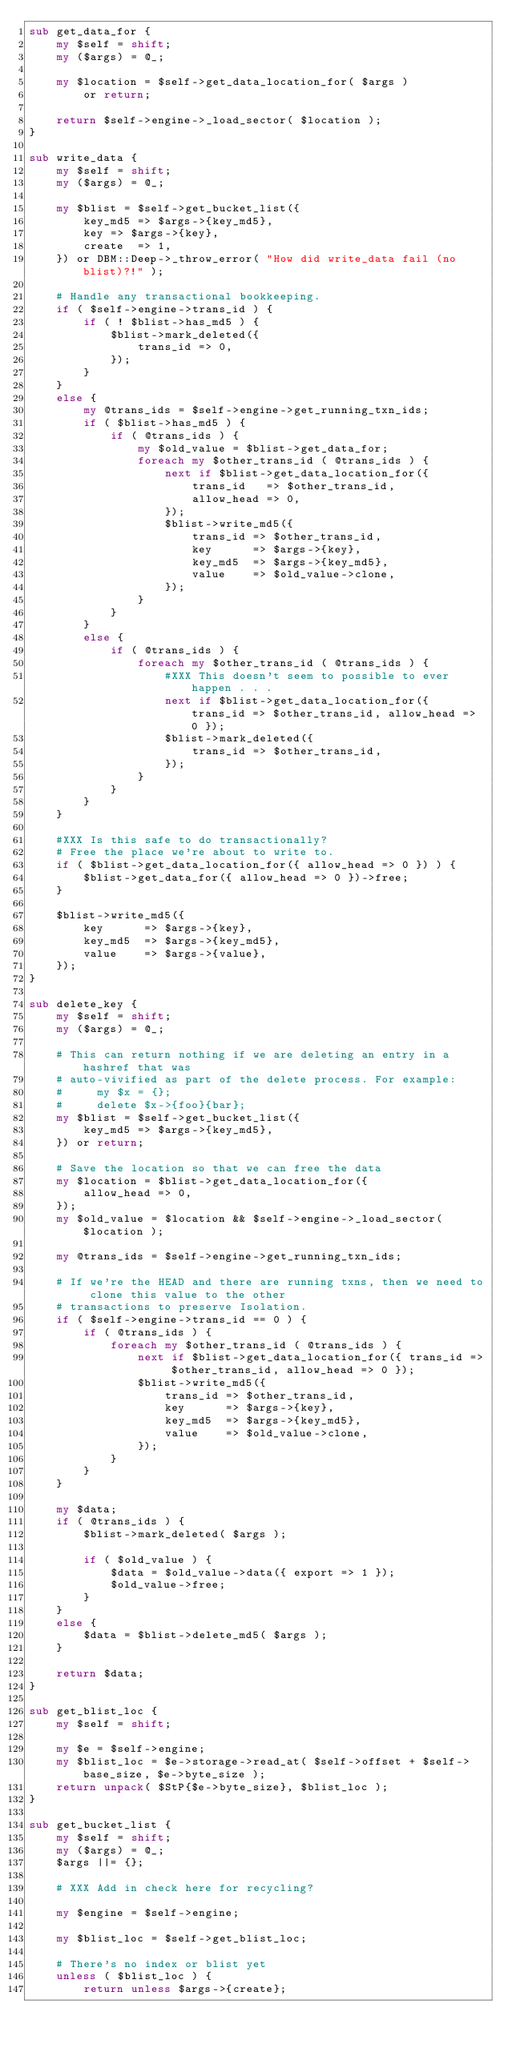Convert code to text. <code><loc_0><loc_0><loc_500><loc_500><_Perl_>sub get_data_for {
    my $self = shift;
    my ($args) = @_;

    my $location = $self->get_data_location_for( $args )
        or return;

    return $self->engine->_load_sector( $location );
}

sub write_data {
    my $self = shift;
    my ($args) = @_;

    my $blist = $self->get_bucket_list({
        key_md5 => $args->{key_md5},
        key => $args->{key},
        create  => 1,
    }) or DBM::Deep->_throw_error( "How did write_data fail (no blist)?!" );

    # Handle any transactional bookkeeping.
    if ( $self->engine->trans_id ) {
        if ( ! $blist->has_md5 ) {
            $blist->mark_deleted({
                trans_id => 0,
            });
        }
    }
    else {
        my @trans_ids = $self->engine->get_running_txn_ids;
        if ( $blist->has_md5 ) {
            if ( @trans_ids ) {
                my $old_value = $blist->get_data_for;
                foreach my $other_trans_id ( @trans_ids ) {
                    next if $blist->get_data_location_for({
                        trans_id   => $other_trans_id,
                        allow_head => 0,
                    });
                    $blist->write_md5({
                        trans_id => $other_trans_id,
                        key      => $args->{key},
                        key_md5  => $args->{key_md5},
                        value    => $old_value->clone,
                    });
                }
            }
        }
        else {
            if ( @trans_ids ) {
                foreach my $other_trans_id ( @trans_ids ) {
                    #XXX This doesn't seem to possible to ever happen . . .
                    next if $blist->get_data_location_for({ trans_id => $other_trans_id, allow_head => 0 });
                    $blist->mark_deleted({
                        trans_id => $other_trans_id,
                    });
                }
            }
        }
    }

    #XXX Is this safe to do transactionally?
    # Free the place we're about to write to.
    if ( $blist->get_data_location_for({ allow_head => 0 }) ) {
        $blist->get_data_for({ allow_head => 0 })->free;
    }

    $blist->write_md5({
        key      => $args->{key},
        key_md5  => $args->{key_md5},
        value    => $args->{value},
    });
}

sub delete_key {
    my $self = shift;
    my ($args) = @_;

    # This can return nothing if we are deleting an entry in a hashref that was
    # auto-vivified as part of the delete process. For example:
    #     my $x = {};
    #     delete $x->{foo}{bar};
    my $blist = $self->get_bucket_list({
        key_md5 => $args->{key_md5},
    }) or return;

    # Save the location so that we can free the data
    my $location = $blist->get_data_location_for({
        allow_head => 0,
    });
    my $old_value = $location && $self->engine->_load_sector( $location );

    my @trans_ids = $self->engine->get_running_txn_ids;

    # If we're the HEAD and there are running txns, then we need to clone this value to the other
    # transactions to preserve Isolation.
    if ( $self->engine->trans_id == 0 ) {
        if ( @trans_ids ) {
            foreach my $other_trans_id ( @trans_ids ) {
                next if $blist->get_data_location_for({ trans_id => $other_trans_id, allow_head => 0 });
                $blist->write_md5({
                    trans_id => $other_trans_id,
                    key      => $args->{key},
                    key_md5  => $args->{key_md5},
                    value    => $old_value->clone,
                });
            }
        }
    }

    my $data;
    if ( @trans_ids ) {
        $blist->mark_deleted( $args );

        if ( $old_value ) {
            $data = $old_value->data({ export => 1 });
            $old_value->free;
        }
    }
    else {
        $data = $blist->delete_md5( $args );
    }

    return $data;
}

sub get_blist_loc {
    my $self = shift;

    my $e = $self->engine;
    my $blist_loc = $e->storage->read_at( $self->offset + $self->base_size, $e->byte_size );
    return unpack( $StP{$e->byte_size}, $blist_loc );
}

sub get_bucket_list {
    my $self = shift;
    my ($args) = @_;
    $args ||= {};

    # XXX Add in check here for recycling?

    my $engine = $self->engine;

    my $blist_loc = $self->get_blist_loc;

    # There's no index or blist yet
    unless ( $blist_loc ) {
        return unless $args->{create};
</code> 